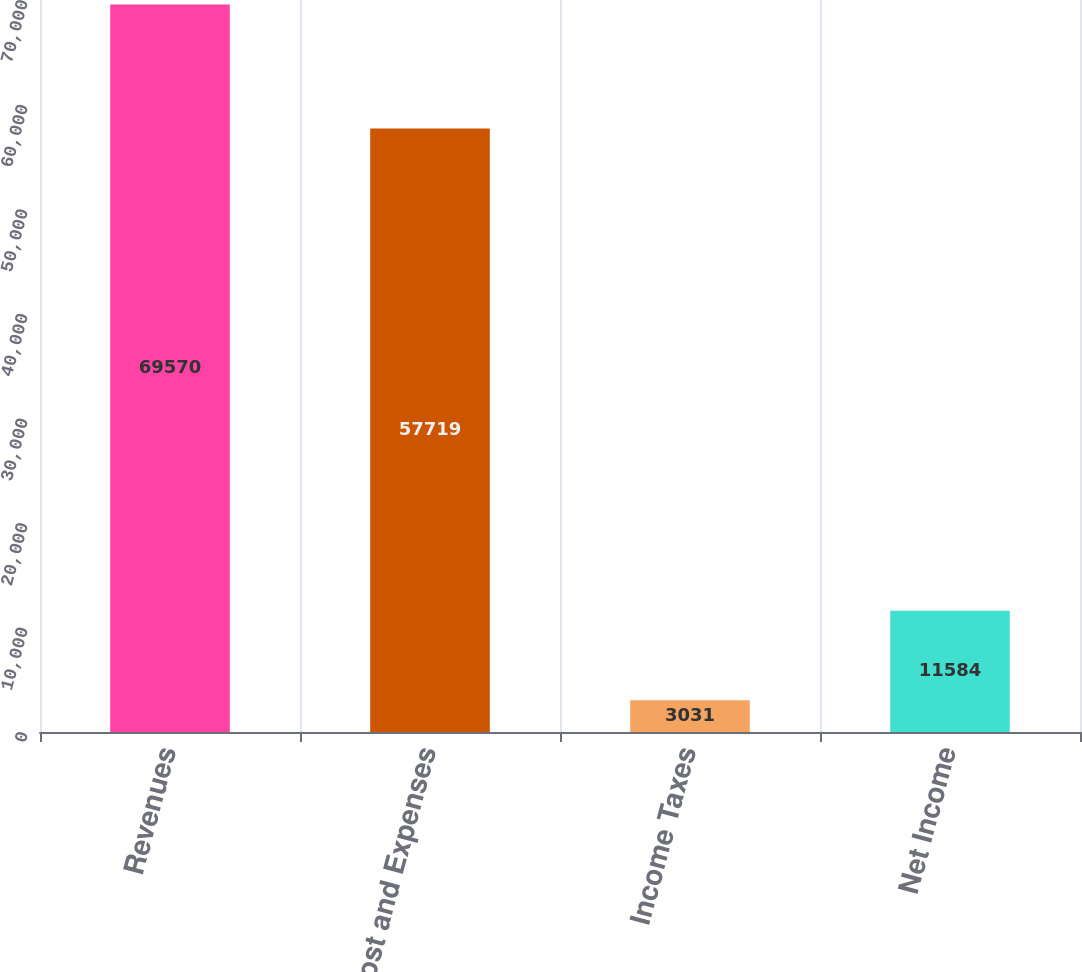<chart> <loc_0><loc_0><loc_500><loc_500><bar_chart><fcel>Revenues<fcel>Cost and Expenses<fcel>Income Taxes<fcel>Net Income<nl><fcel>69570<fcel>57719<fcel>3031<fcel>11584<nl></chart> 